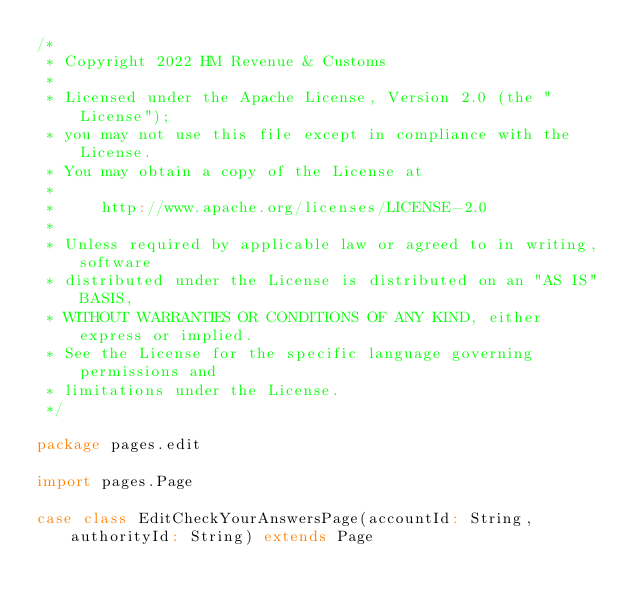Convert code to text. <code><loc_0><loc_0><loc_500><loc_500><_Scala_>/*
 * Copyright 2022 HM Revenue & Customs
 *
 * Licensed under the Apache License, Version 2.0 (the "License");
 * you may not use this file except in compliance with the License.
 * You may obtain a copy of the License at
 *
 *     http://www.apache.org/licenses/LICENSE-2.0
 *
 * Unless required by applicable law or agreed to in writing, software
 * distributed under the License is distributed on an "AS IS" BASIS,
 * WITHOUT WARRANTIES OR CONDITIONS OF ANY KIND, either express or implied.
 * See the License for the specific language governing permissions and
 * limitations under the License.
 */

package pages.edit

import pages.Page

case class EditCheckYourAnswersPage(accountId: String, authorityId: String) extends Page
</code> 